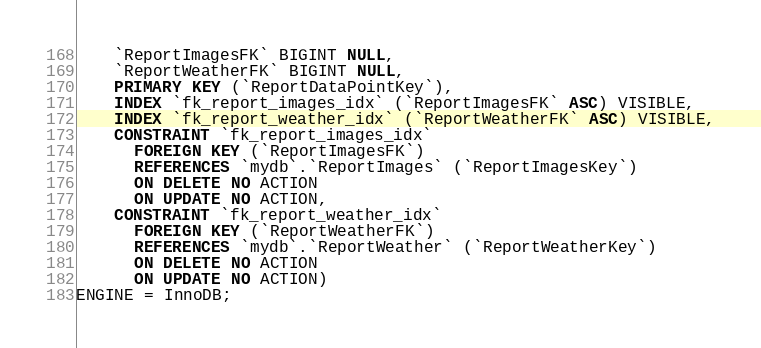Convert code to text. <code><loc_0><loc_0><loc_500><loc_500><_SQL_>    `ReportImagesFK` BIGINT NULL,
	`ReportWeatherFK` BIGINT NULL,
    PRIMARY KEY (`ReportDataPointKey`),
    INDEX `fk_report_images_idx` (`ReportImagesFK` ASC) VISIBLE,
	INDEX `fk_report_weather_idx` (`ReportWeatherFK` ASC) VISIBLE,
	CONSTRAINT `fk_report_images_idx`
	  FOREIGN KEY (`ReportImagesFK`)
      REFERENCES `mydb`.`ReportImages` (`ReportImagesKey`)
      ON DELETE NO ACTION
      ON UPDATE NO ACTION,
	CONSTRAINT `fk_report_weather_idx`
	  FOREIGN KEY (`ReportWeatherFK`)
	  REFERENCES `mydb`.`ReportWeather` (`ReportWeatherKey`)
	  ON DELETE NO ACTION
	  ON UPDATE NO ACTION)
ENGINE = InnoDB;

</code> 